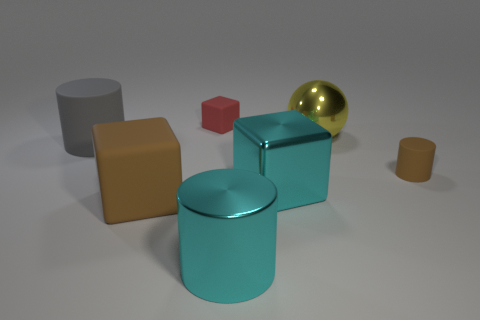Is the color of the tiny thing that is in front of the red rubber block the same as the big metallic block?
Make the answer very short. No. How many objects are either big things that are in front of the big metal cube or matte cylinders that are left of the large yellow metal object?
Give a very brief answer. 3. How many matte things are left of the small cylinder and to the right of the large gray rubber thing?
Your answer should be compact. 2. Do the large ball and the tiny brown thing have the same material?
Ensure brevity in your answer.  No. What is the shape of the small thing behind the cylinder on the left side of the brown rubber object that is in front of the small matte cylinder?
Make the answer very short. Cube. There is a object that is both to the left of the small red matte object and in front of the tiny cylinder; what material is it?
Keep it short and to the point. Rubber. There is a matte cylinder that is to the left of the small matte object that is right of the tiny thing behind the big sphere; what color is it?
Keep it short and to the point. Gray. What number of blue objects are either big rubber cylinders or matte blocks?
Give a very brief answer. 0. What number of other objects are the same size as the red matte block?
Make the answer very short. 1. How many gray matte cylinders are there?
Offer a terse response. 1. 